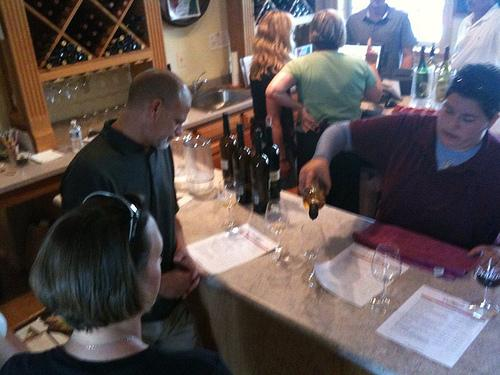What kind of wine is the man serving in the glasses? Please explain your reasoning. white. It is a see through liquid. 